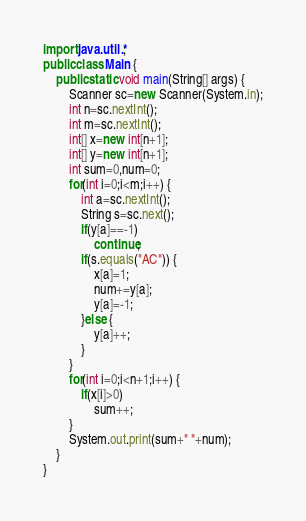<code> <loc_0><loc_0><loc_500><loc_500><_Java_>import java.util.*;
public class Main {
	public static void main(String[] args) {
		Scanner sc=new Scanner(System.in);
		int n=sc.nextInt();
		int m=sc.nextInt();
		int[] x=new int[n+1];
		int[] y=new int[n+1];
		int sum=0,num=0;
		for(int i=0;i<m;i++) {
			int a=sc.nextInt();
			String s=sc.next();
			if(y[a]==-1)
				continue;
			if(s.equals("AC")) {
				x[a]=1;
				num+=y[a];
				y[a]=-1;
			}else {
				y[a]++;
			}
		}
		for(int i=0;i<n+1;i++) {
			if(x[i]>0)
				sum++;
		}
		System.out.print(sum+" "+num);
	}
} </code> 